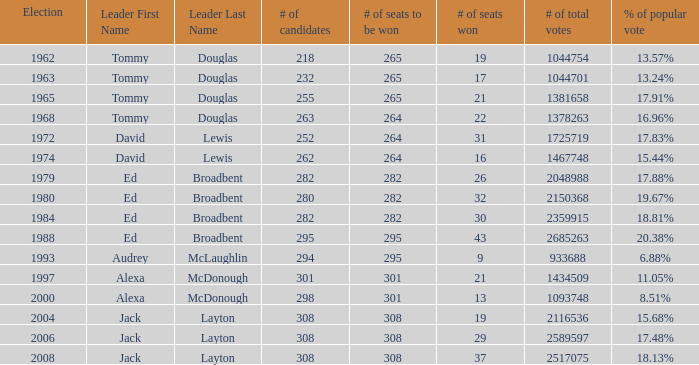Name the number of candidates for # of seats won being 43 295.0. 